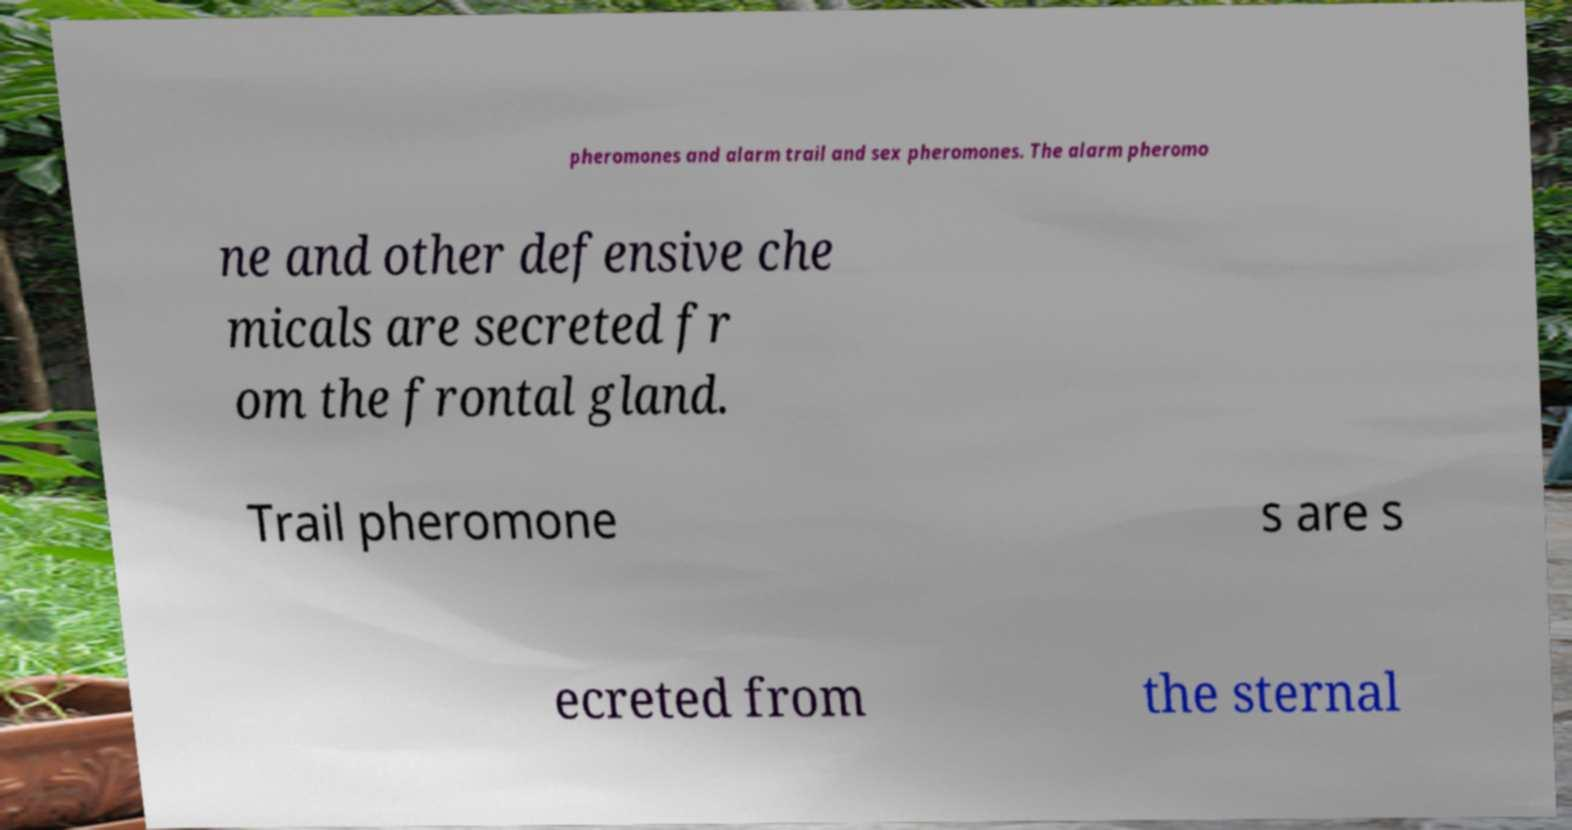For documentation purposes, I need the text within this image transcribed. Could you provide that? pheromones and alarm trail and sex pheromones. The alarm pheromo ne and other defensive che micals are secreted fr om the frontal gland. Trail pheromone s are s ecreted from the sternal 